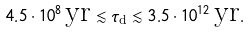Convert formula to latex. <formula><loc_0><loc_0><loc_500><loc_500>4 . 5 \cdot 1 0 ^ { 8 } \, \text {yr} \lesssim \tau _ { \text {d} } \lesssim 3 . 5 \cdot 1 0 ^ { 1 2 } \, \text {yr} .</formula> 